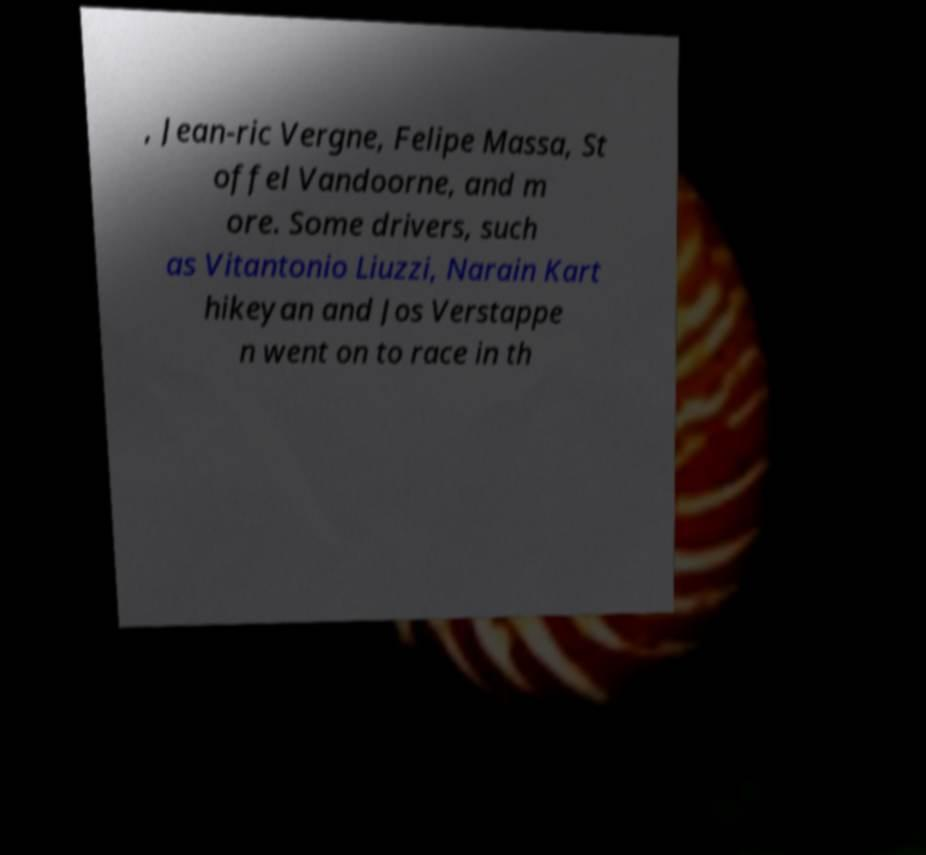Could you assist in decoding the text presented in this image and type it out clearly? , Jean-ric Vergne, Felipe Massa, St offel Vandoorne, and m ore. Some drivers, such as Vitantonio Liuzzi, Narain Kart hikeyan and Jos Verstappe n went on to race in th 